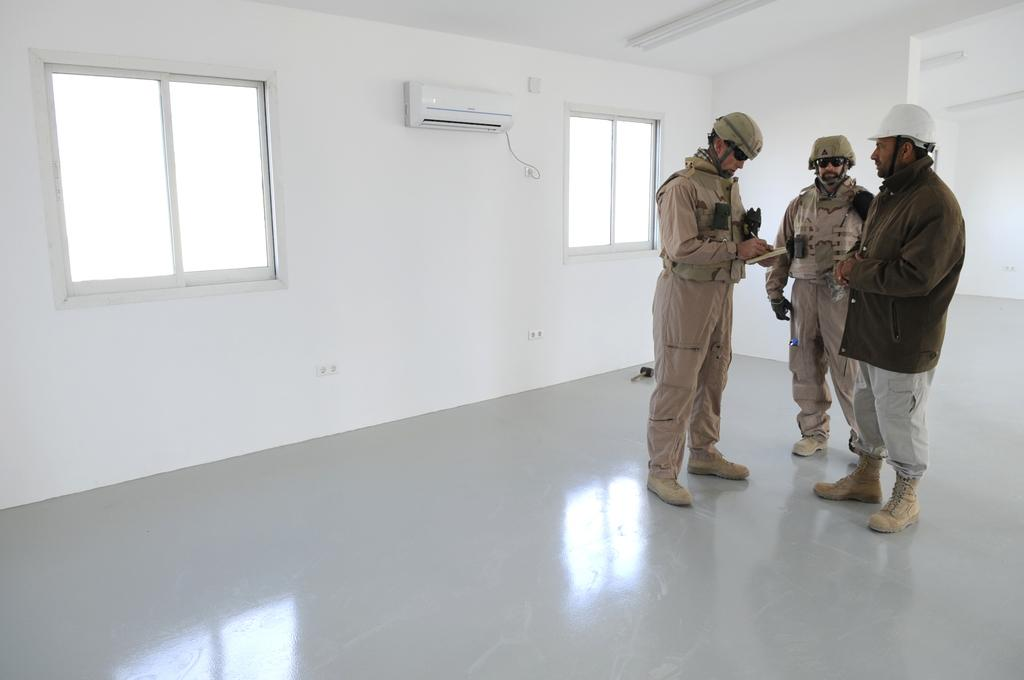What are the main subjects in the image? There are persons standing in the center of the image. What can be seen in the background of the image? There are windows and an air conditioner on the wall. Can you describe any other details in the image? There is a wire visible. What type of rifle is being used by the persons in the image? There is no rifle present in the image; the persons are simply standing. 